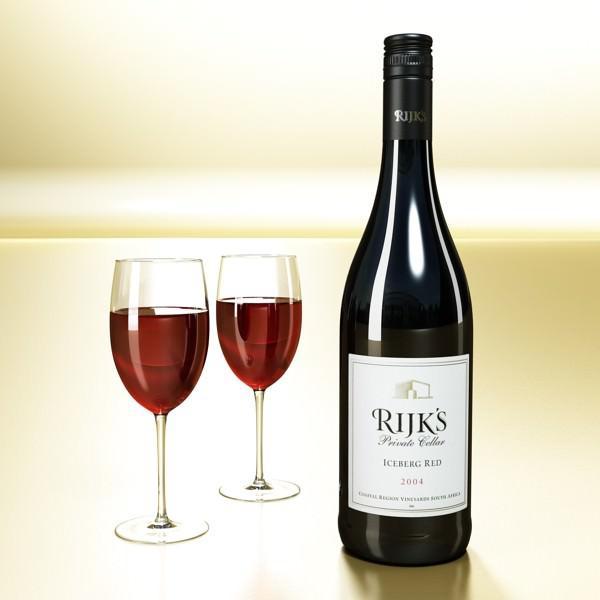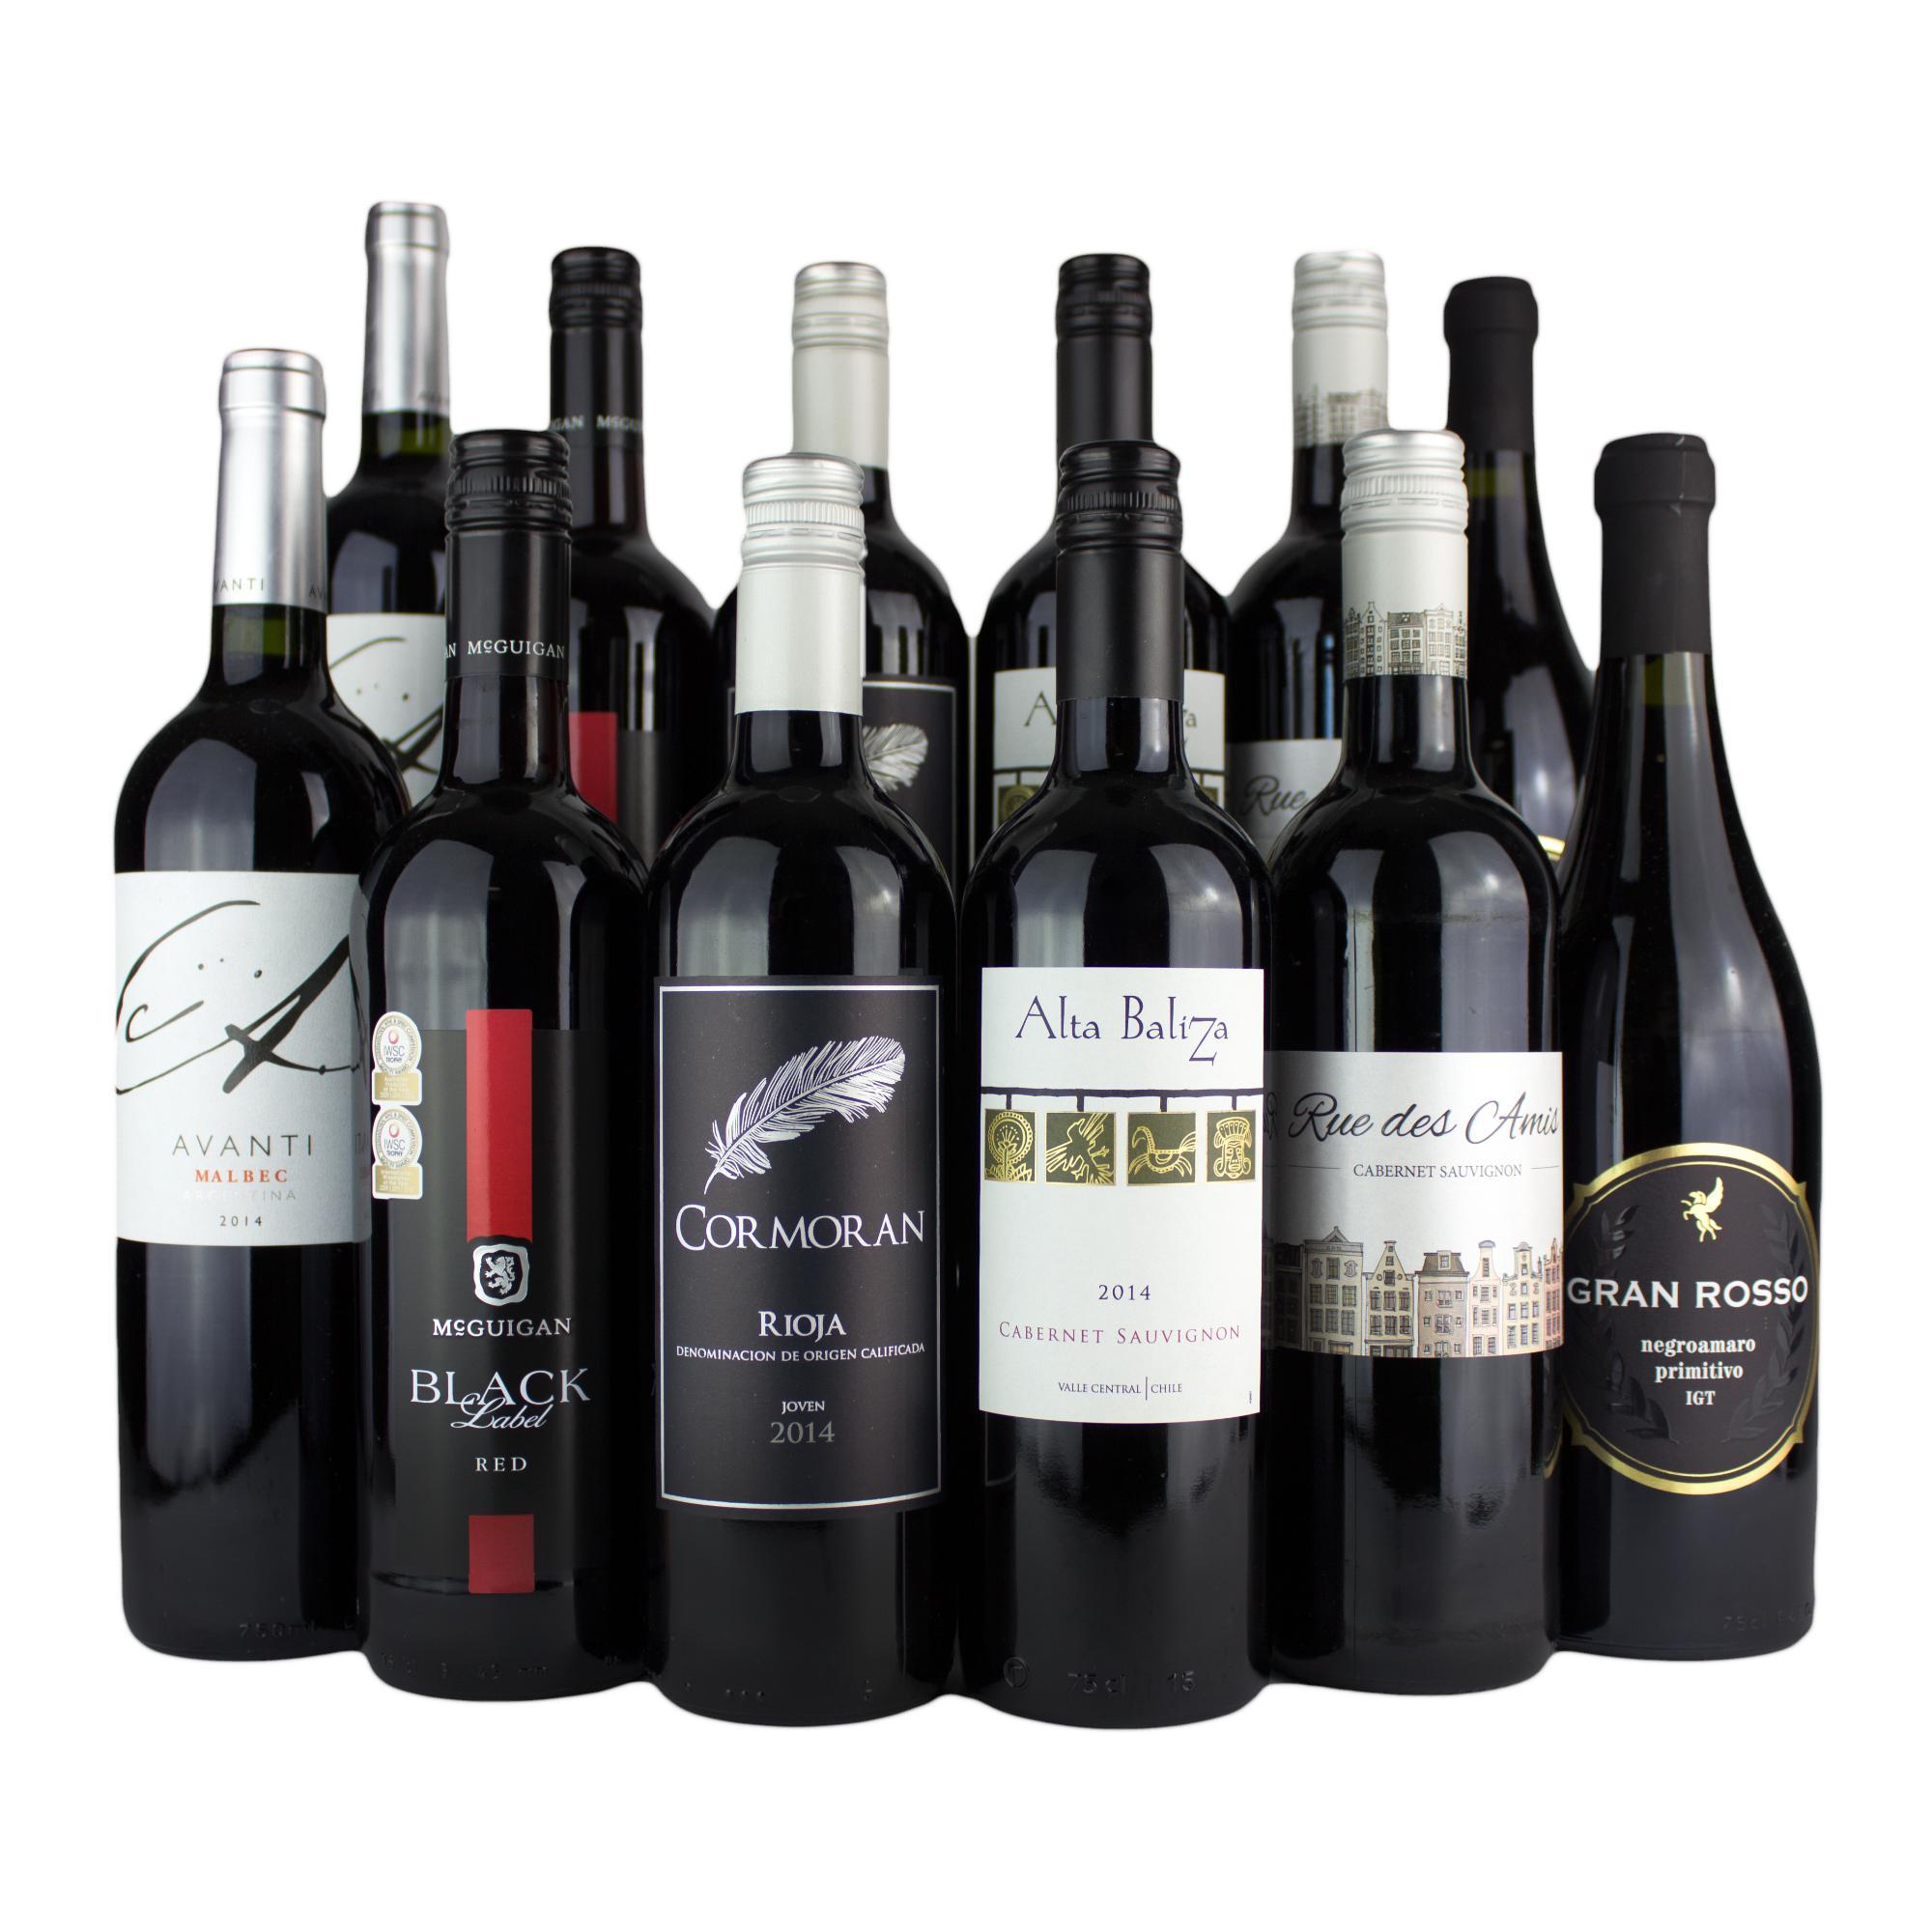The first image is the image on the left, the second image is the image on the right. Assess this claim about the two images: "There are at least six wine bottles in one of the images.". Correct or not? Answer yes or no. Yes. The first image is the image on the left, the second image is the image on the right. Analyze the images presented: Is the assertion "In one of the images, there are two glasses of red wine side by side" valid? Answer yes or no. Yes. 